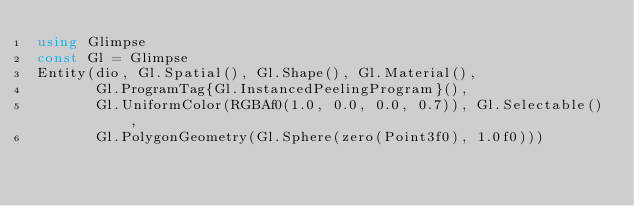<code> <loc_0><loc_0><loc_500><loc_500><_Julia_>using Glimpse
const Gl = Glimpse
Entity(dio, Gl.Spatial(), Gl.Shape(), Gl.Material(),
       Gl.ProgramTag{Gl.InstancedPeelingProgram}(),
       Gl.UniformColor(RGBAf0(1.0, 0.0, 0.0, 0.7)), Gl.Selectable(),
       Gl.PolygonGeometry(Gl.Sphere(zero(Point3f0), 1.0f0)))
</code> 